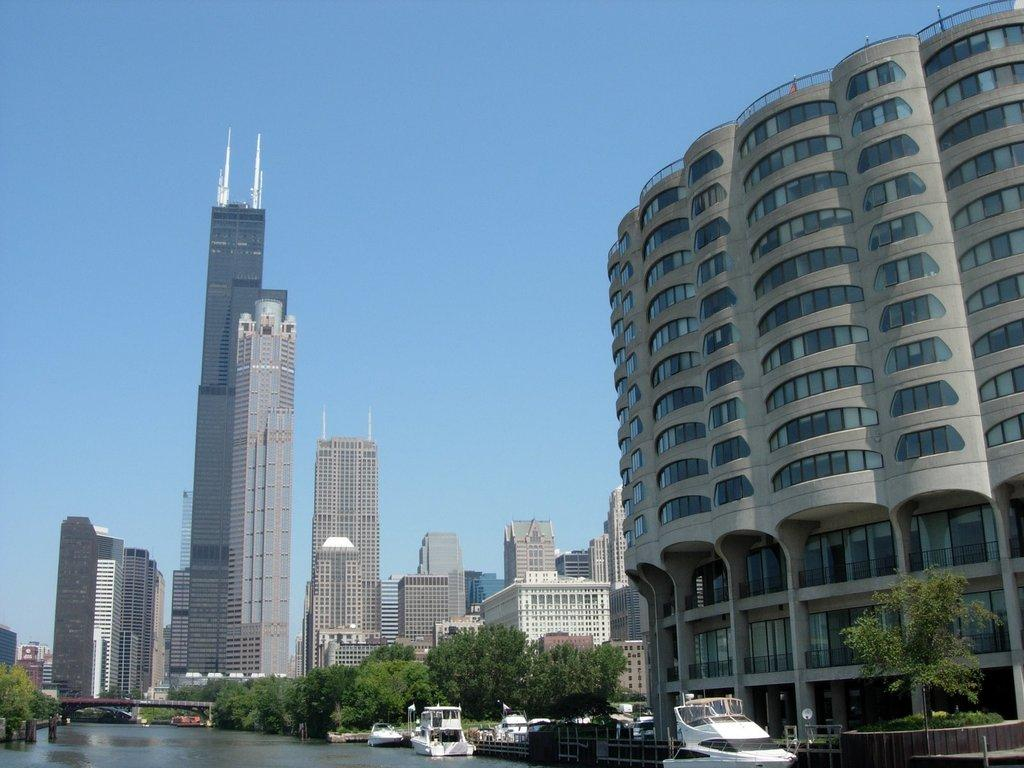What is positioned above the water in the image? There are boats above the water in the image. What type of structure can be seen in the image? There is a bridge in the image. What type of vegetation is present in the image? There are trees in the image. What safety feature can be seen in the image? There are railings in the image. What type of man-made structures are visible in the image? There are buildings in the image. What is visible in the background of the image? The sky is visible in the background of the image. Can you tell me how many bubbles are floating around the boats in the image? There are no bubbles present in the image; it features boats above the water. What type of expert is standing near the bridge in the image? There is no expert present in the image; it only features boats, a bridge, trees, railings, buildings, and the sky. 